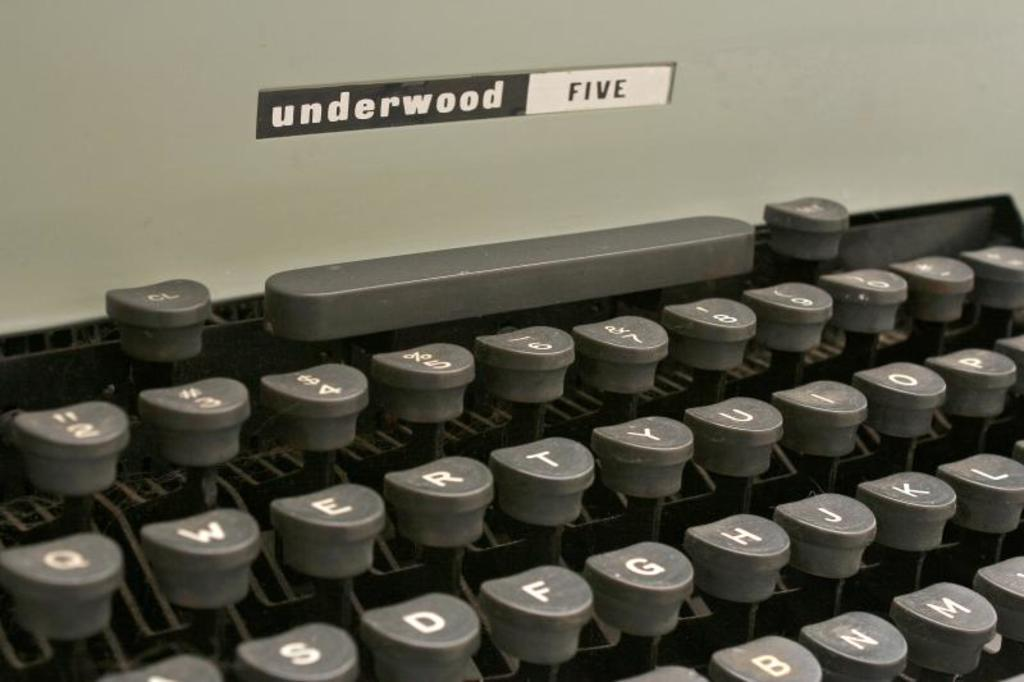Provide a one-sentence caption for the provided image. A old fashion brand of typewriter underwood five is pictured. 